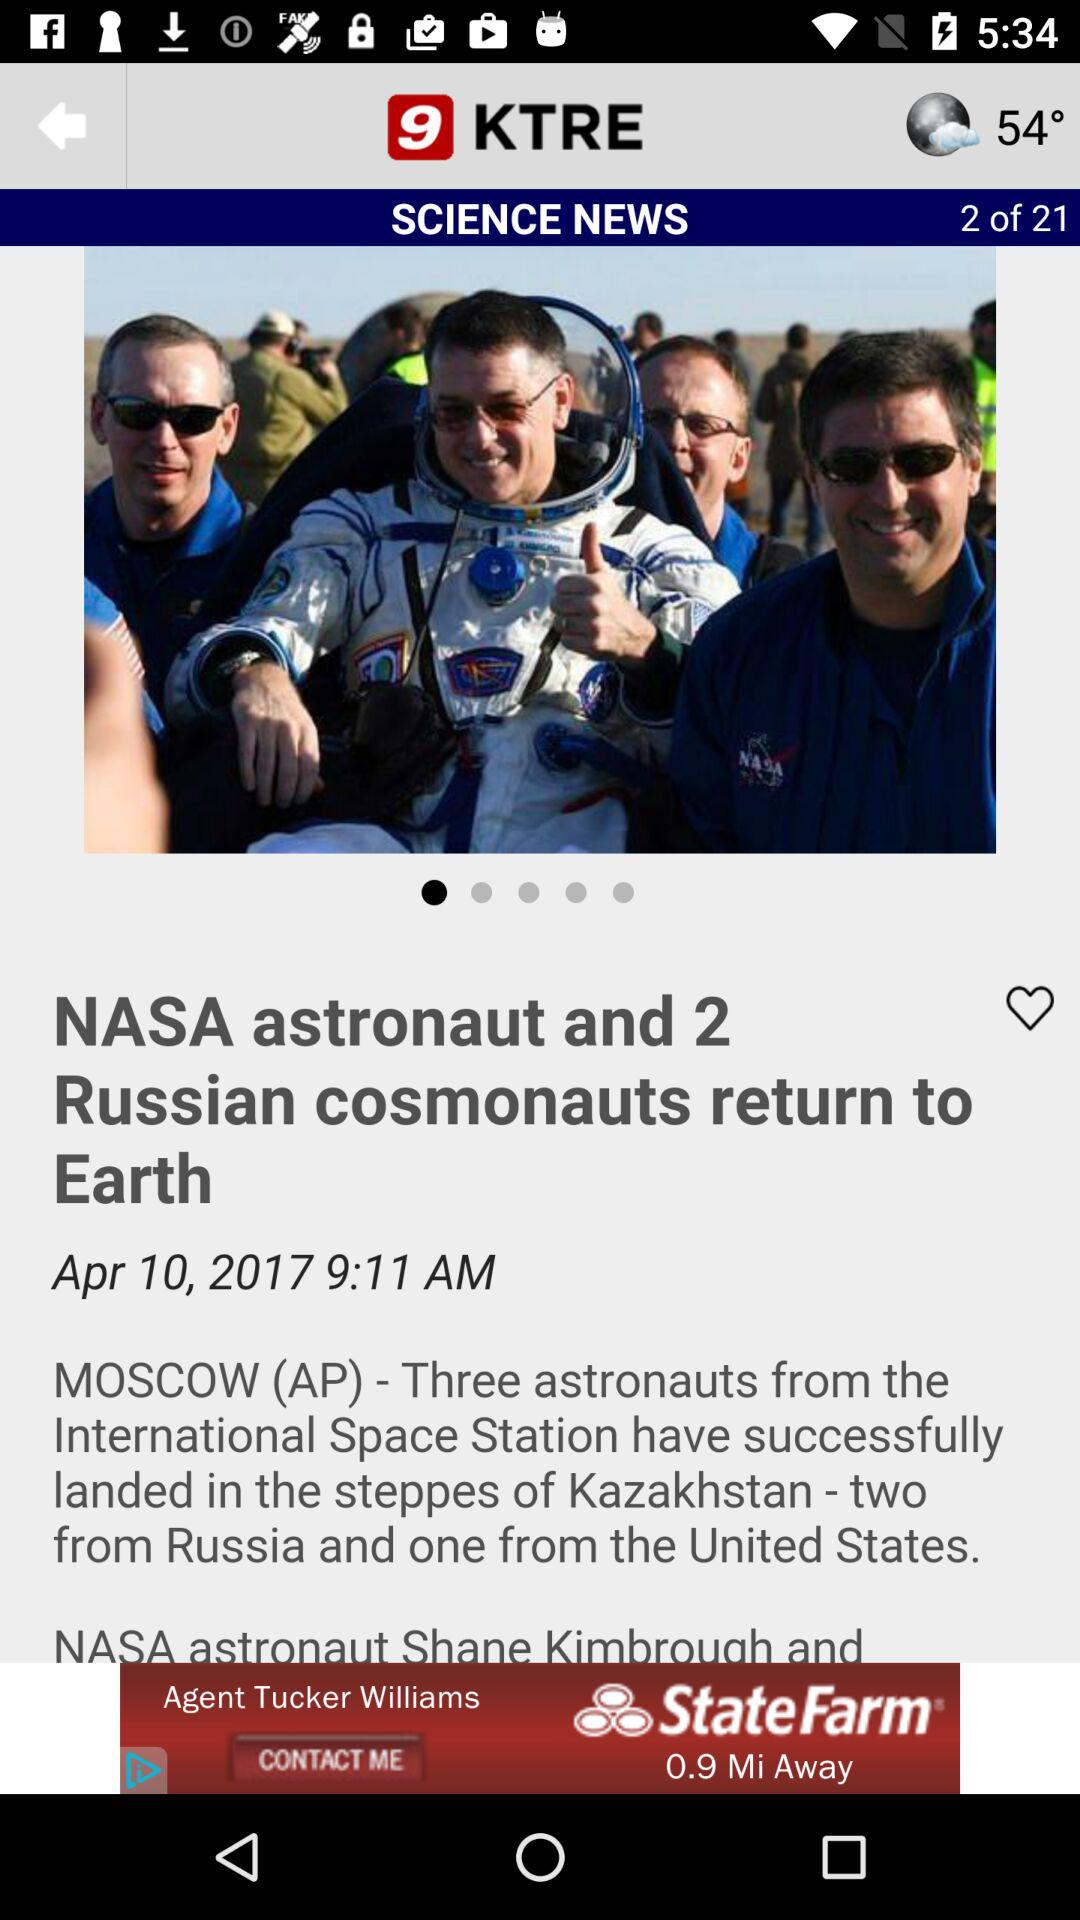On which date was the news "NASA astronaut and 2 Russian cosmonauts return to Earth" posted? The news "NASA astronaut and 2 Russian cosmonauts return to Earth" was posted on April 10, 2017. 